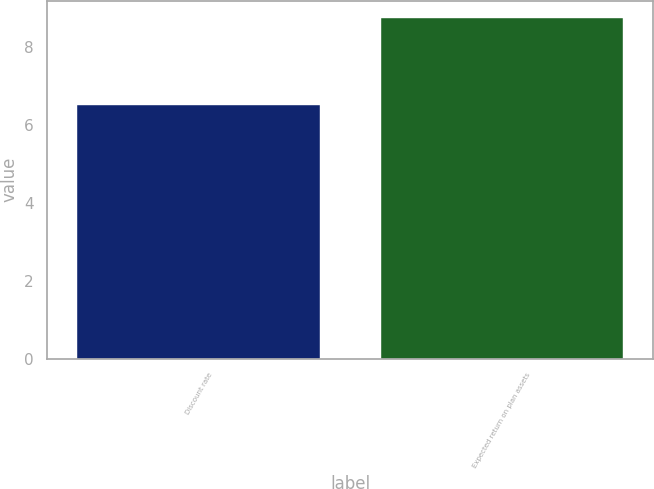Convert chart to OTSL. <chart><loc_0><loc_0><loc_500><loc_500><bar_chart><fcel>Discount rate<fcel>Expected return on plan assets<nl><fcel>6.5<fcel>8.75<nl></chart> 